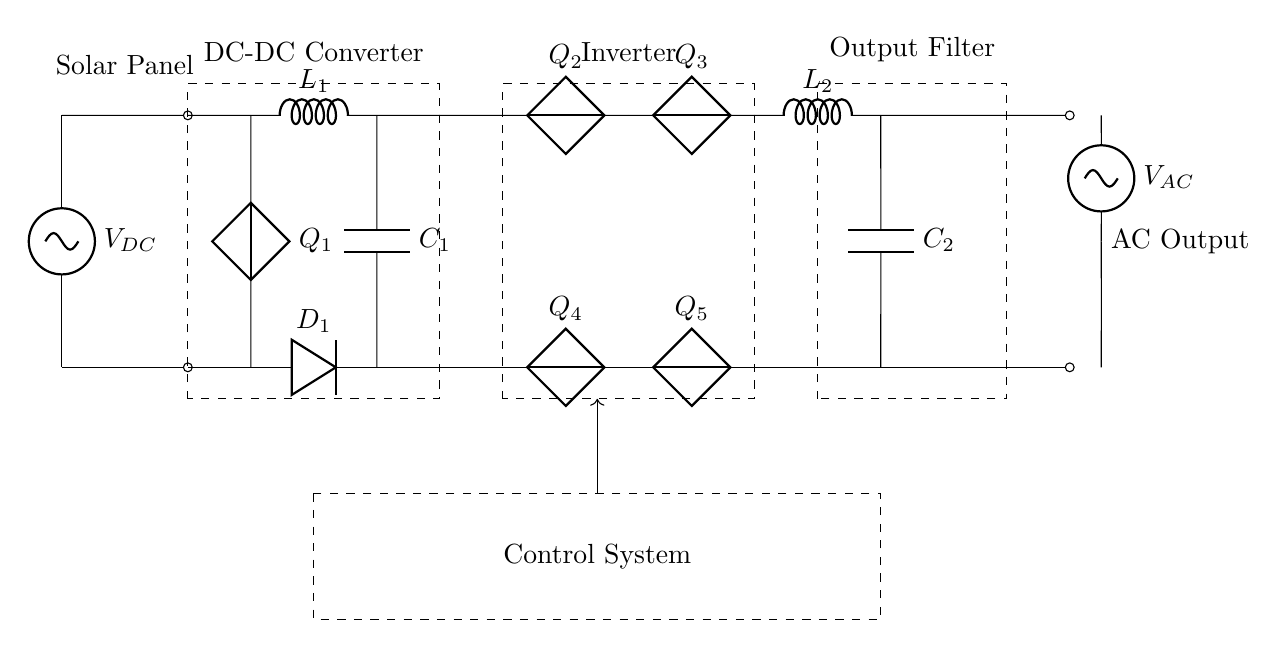What is the type of power output from the inverter? The inverter converts the DC from the solar panel to AC, which is indicated by the sinusoidal voltage source labeled V_AC in the circuit.
Answer: AC What is the role of the DC-DC converter in the circuit? The DC-DC converter steps up or down the DC voltage from the solar panel to match the requirements of the inverter, ensuring the correct voltage level for efficient operation.
Answer: Voltage adjustment What is the function of the control system in this inverter circuit? The control system manages the operation of the inverter and regulates the output to maintain stability and efficiency, highlighted by the dashed box around it in the circuit diagram.
Answer: Regulation How many DC capacitors are present in the inverter section? There are two capacitors labeled Q_2 and Q_4 in the inverter section, used for filtering and smoothing the output waveform.
Answer: Two What is the inductor labeled L_2 used for in the output filter? The inductor L_2 in the output filter serves to further smooth the output current, reducing ripple and improving the quality of the AC signal sent to the load.
Answer: Smoothing Which component is responsible for converting the DC voltage to AC voltage? The components labeled Q_2, Q_3, Q_4, and Q_5 are the switches (transistors or MOSFETs) that are utilized in a configuration to alternate the DC input, effectively producing the AC output.
Answer: Switches What kind of load is this inverter circuit designed to support? This inverter is designed for residential photovoltaic systems, indicating it can handle various household appliances like lights, refrigerators, and HVAC systems.
Answer: Residential appliances 